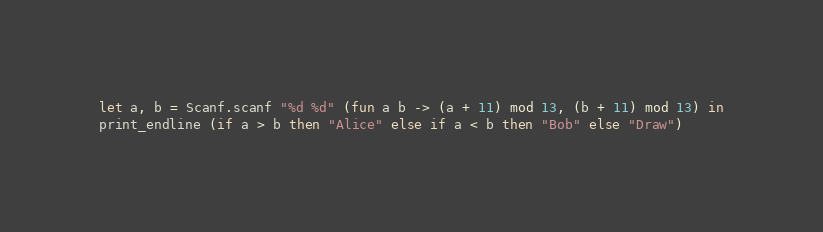Convert code to text. <code><loc_0><loc_0><loc_500><loc_500><_OCaml_>let a, b = Scanf.scanf "%d %d" (fun a b -> (a + 11) mod 13, (b + 11) mod 13) in
print_endline (if a > b then "Alice" else if a < b then "Bob" else "Draw")
</code> 